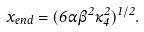Convert formula to latex. <formula><loc_0><loc_0><loc_500><loc_500>x _ { e n d } = ( 6 \alpha \beta ^ { 2 } \kappa _ { 4 } ^ { 2 } ) ^ { 1 / 2 } .</formula> 